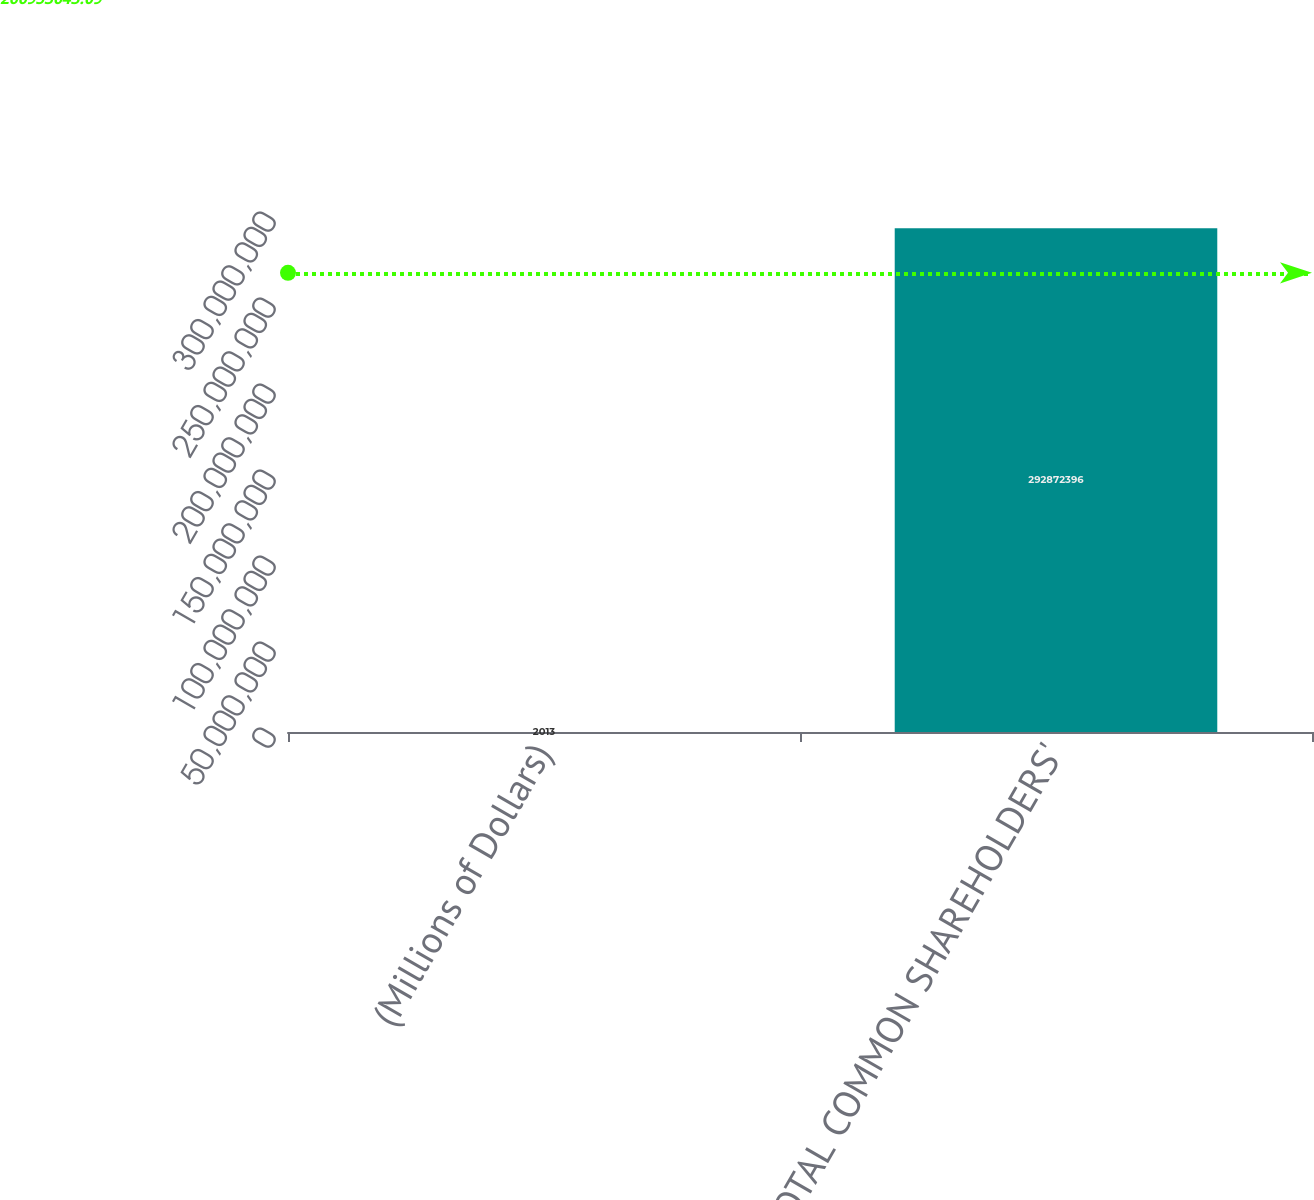Convert chart. <chart><loc_0><loc_0><loc_500><loc_500><bar_chart><fcel>(Millions of Dollars)<fcel>TOTAL COMMON SHAREHOLDERS'<nl><fcel>2013<fcel>2.92872e+08<nl></chart> 